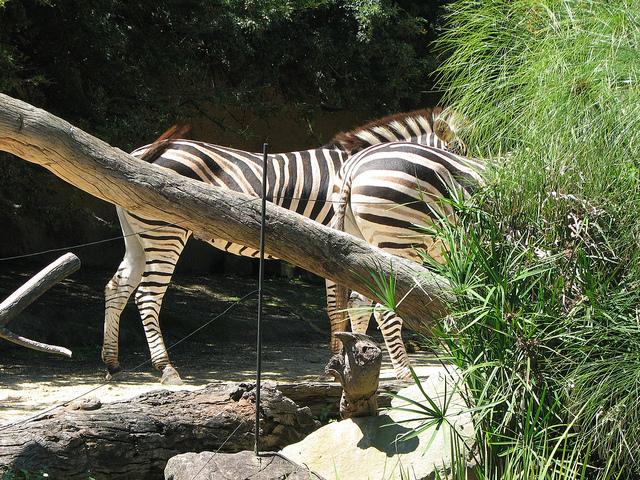Where is the fence?
Answer briefly. In front. How many animals are shown?
Short answer required. 2. What kind of animal is shown?
Short answer required. Zebra. 